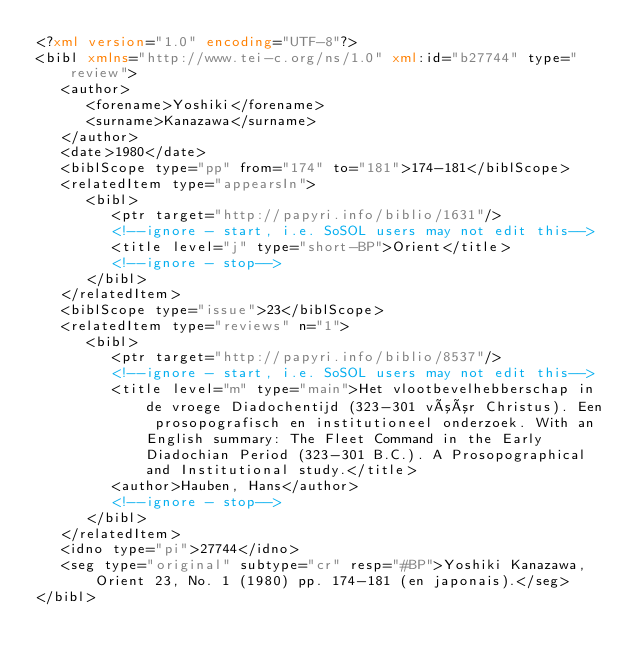<code> <loc_0><loc_0><loc_500><loc_500><_XML_><?xml version="1.0" encoding="UTF-8"?>
<bibl xmlns="http://www.tei-c.org/ns/1.0" xml:id="b27744" type="review">
   <author>
      <forename>Yoshiki</forename>
      <surname>Kanazawa</surname>
   </author>
   <date>1980</date>
   <biblScope type="pp" from="174" to="181">174-181</biblScope>
   <relatedItem type="appearsIn">
      <bibl>
         <ptr target="http://papyri.info/biblio/1631"/>
         <!--ignore - start, i.e. SoSOL users may not edit this-->
         <title level="j" type="short-BP">Orient</title>
         <!--ignore - stop-->
      </bibl>
   </relatedItem>
   <biblScope type="issue">23</biblScope>
   <relatedItem type="reviews" n="1">
      <bibl>
         <ptr target="http://papyri.info/biblio/8537"/>
         <!--ignore - start, i.e. SoSOL users may not edit this-->
         <title level="m" type="main">Het vlootbevelhebberschap in de vroege Diadochentijd (323-301 vóór Christus). Een prosopografisch en institutioneel onderzoek. With an English summary: The Fleet Command in the Early Diadochian Period (323-301 B.C.). A Prosopographical and Institutional study.</title>
         <author>Hauben, Hans</author>
         <!--ignore - stop-->
      </bibl>
   </relatedItem>
   <idno type="pi">27744</idno>
   <seg type="original" subtype="cr" resp="#BP">Yoshiki Kanazawa, Orient 23, No. 1 (1980) pp. 174-181 (en japonais).</seg>
</bibl>
</code> 